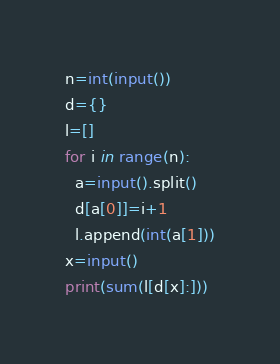<code> <loc_0><loc_0><loc_500><loc_500><_Cython_>n=int(input())
d={}
l=[]
for i in range(n):
  a=input().split()
  d[a[0]]=i+1
  l.append(int(a[1]))
x=input()
print(sum(l[d[x]:]))</code> 